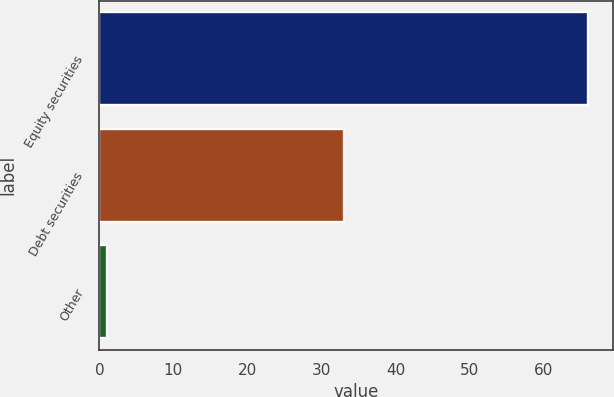<chart> <loc_0><loc_0><loc_500><loc_500><bar_chart><fcel>Equity securities<fcel>Debt securities<fcel>Other<nl><fcel>66<fcel>33<fcel>1<nl></chart> 